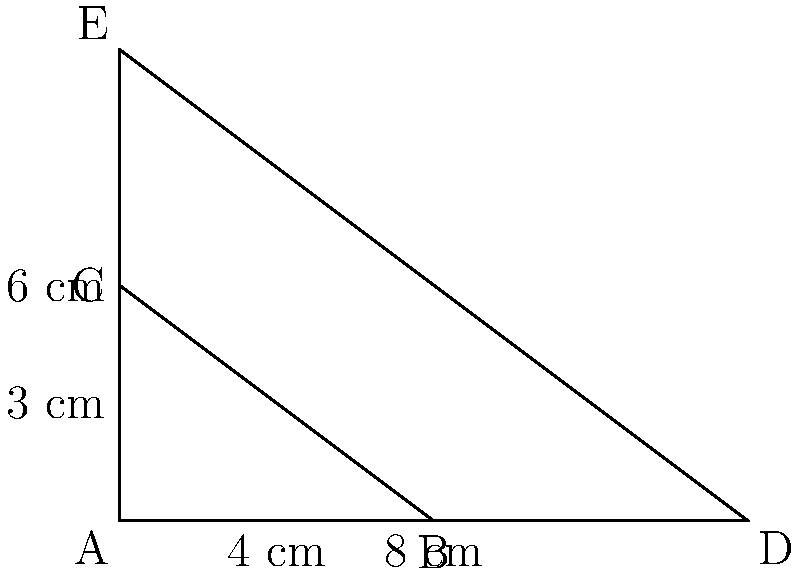An architectural firm is designing a scale model of a triangular building. The original building has a base of 80 meters and a height of 60 meters. In the scale model shown, triangle ABC represents the original building, while triangle ADE represents the scale model. Given that the base of the scale model (AD) is 8 cm, what is the scale factor of the model, and what real-world distance does 1 cm in the model represent? To solve this problem, we'll use the properties of similar triangles and their scale factors. Let's approach this step-by-step:

1) First, let's identify the scale factor between the model and the real building:

   Scale factor = Model dimension / Real dimension

2) We know the base of the scale model (AD) is 8 cm, and the real building's base is 80 meters.
   To use the same units, let's convert 80 meters to centimeters:
   80 meters = 8000 cm

3) Now we can calculate the scale factor:
   Scale factor = 8 cm / 8000 cm = 1/1000 = 0.001

4) To verify this scale factor, we can check if it applies to the height as well:
   Real height: 60 meters = 6000 cm
   Model height (AE): 6 cm
   6 cm / 6000 cm = 1/1000 = 0.001

   This confirms our scale factor.

5) To determine what real-world distance 1 cm in the model represents:
   If 0.001 of the real distance = 1 cm in the model,
   Then 1 cm in the model = 1 / 0.001 = 1000 cm = 10 meters in real life

Therefore, the scale factor is 0.001, or 1:1000, and 1 cm in the model represents 10 meters in the real world.
Answer: Scale factor: 0.001 (1:1000); 1 cm represents 10 meters 